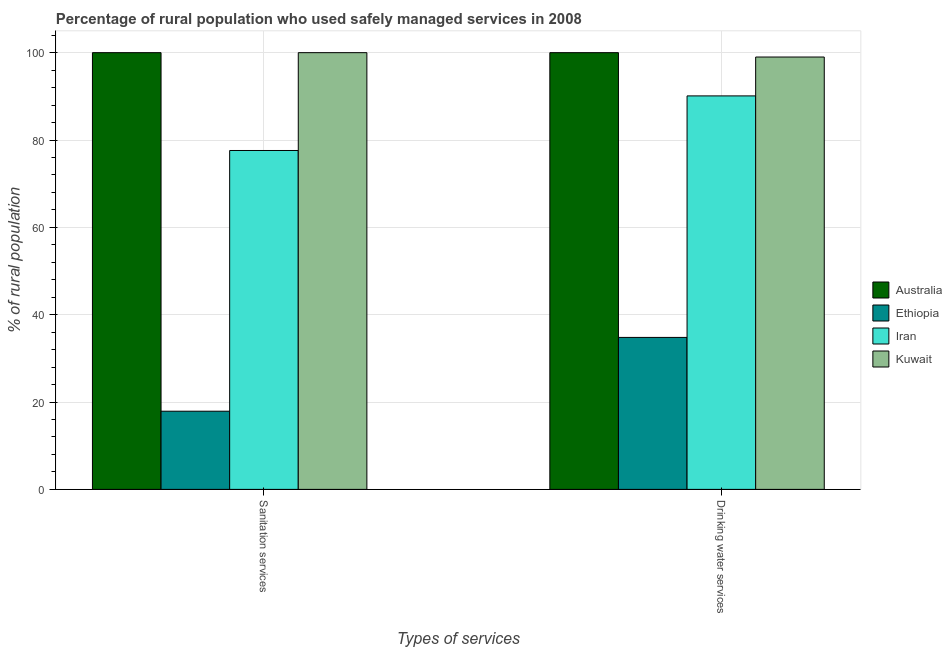How many groups of bars are there?
Your response must be concise. 2. Are the number of bars per tick equal to the number of legend labels?
Your response must be concise. Yes. Are the number of bars on each tick of the X-axis equal?
Provide a short and direct response. Yes. How many bars are there on the 1st tick from the left?
Your answer should be very brief. 4. How many bars are there on the 1st tick from the right?
Provide a short and direct response. 4. What is the label of the 1st group of bars from the left?
Your answer should be compact. Sanitation services. What is the percentage of rural population who used drinking water services in Ethiopia?
Keep it short and to the point. 34.8. Across all countries, what is the minimum percentage of rural population who used drinking water services?
Give a very brief answer. 34.8. In which country was the percentage of rural population who used sanitation services minimum?
Offer a very short reply. Ethiopia. What is the total percentage of rural population who used sanitation services in the graph?
Provide a succinct answer. 295.5. What is the difference between the percentage of rural population who used drinking water services in Ethiopia and that in Iran?
Give a very brief answer. -55.3. What is the difference between the percentage of rural population who used sanitation services in Kuwait and the percentage of rural population who used drinking water services in Iran?
Keep it short and to the point. 9.9. What is the average percentage of rural population who used drinking water services per country?
Offer a terse response. 80.97. What is the ratio of the percentage of rural population who used sanitation services in Iran to that in Australia?
Make the answer very short. 0.78. What does the 3rd bar from the left in Drinking water services represents?
Provide a short and direct response. Iran. What does the 1st bar from the right in Sanitation services represents?
Provide a short and direct response. Kuwait. How many bars are there?
Your answer should be compact. 8. How many countries are there in the graph?
Your answer should be very brief. 4. Where does the legend appear in the graph?
Provide a short and direct response. Center right. How are the legend labels stacked?
Ensure brevity in your answer.  Vertical. What is the title of the graph?
Your answer should be very brief. Percentage of rural population who used safely managed services in 2008. Does "Andorra" appear as one of the legend labels in the graph?
Your answer should be compact. No. What is the label or title of the X-axis?
Offer a very short reply. Types of services. What is the label or title of the Y-axis?
Your answer should be compact. % of rural population. What is the % of rural population in Australia in Sanitation services?
Give a very brief answer. 100. What is the % of rural population in Iran in Sanitation services?
Keep it short and to the point. 77.6. What is the % of rural population of Kuwait in Sanitation services?
Give a very brief answer. 100. What is the % of rural population of Ethiopia in Drinking water services?
Provide a succinct answer. 34.8. What is the % of rural population of Iran in Drinking water services?
Offer a very short reply. 90.1. Across all Types of services, what is the maximum % of rural population in Australia?
Offer a terse response. 100. Across all Types of services, what is the maximum % of rural population of Ethiopia?
Give a very brief answer. 34.8. Across all Types of services, what is the maximum % of rural population of Iran?
Your answer should be compact. 90.1. Across all Types of services, what is the minimum % of rural population in Australia?
Give a very brief answer. 100. Across all Types of services, what is the minimum % of rural population in Iran?
Provide a short and direct response. 77.6. What is the total % of rural population of Ethiopia in the graph?
Offer a terse response. 52.7. What is the total % of rural population of Iran in the graph?
Provide a short and direct response. 167.7. What is the total % of rural population in Kuwait in the graph?
Offer a terse response. 199. What is the difference between the % of rural population of Ethiopia in Sanitation services and that in Drinking water services?
Your response must be concise. -16.9. What is the difference between the % of rural population in Kuwait in Sanitation services and that in Drinking water services?
Make the answer very short. 1. What is the difference between the % of rural population in Australia in Sanitation services and the % of rural population in Ethiopia in Drinking water services?
Give a very brief answer. 65.2. What is the difference between the % of rural population in Ethiopia in Sanitation services and the % of rural population in Iran in Drinking water services?
Your answer should be very brief. -72.2. What is the difference between the % of rural population of Ethiopia in Sanitation services and the % of rural population of Kuwait in Drinking water services?
Give a very brief answer. -81.1. What is the difference between the % of rural population in Iran in Sanitation services and the % of rural population in Kuwait in Drinking water services?
Ensure brevity in your answer.  -21.4. What is the average % of rural population in Australia per Types of services?
Your response must be concise. 100. What is the average % of rural population of Ethiopia per Types of services?
Provide a short and direct response. 26.35. What is the average % of rural population in Iran per Types of services?
Your answer should be very brief. 83.85. What is the average % of rural population of Kuwait per Types of services?
Make the answer very short. 99.5. What is the difference between the % of rural population of Australia and % of rural population of Ethiopia in Sanitation services?
Make the answer very short. 82.1. What is the difference between the % of rural population of Australia and % of rural population of Iran in Sanitation services?
Your answer should be compact. 22.4. What is the difference between the % of rural population in Australia and % of rural population in Kuwait in Sanitation services?
Offer a terse response. 0. What is the difference between the % of rural population of Ethiopia and % of rural population of Iran in Sanitation services?
Your answer should be very brief. -59.7. What is the difference between the % of rural population of Ethiopia and % of rural population of Kuwait in Sanitation services?
Provide a succinct answer. -82.1. What is the difference between the % of rural population of Iran and % of rural population of Kuwait in Sanitation services?
Make the answer very short. -22.4. What is the difference between the % of rural population in Australia and % of rural population in Ethiopia in Drinking water services?
Your answer should be very brief. 65.2. What is the difference between the % of rural population of Australia and % of rural population of Iran in Drinking water services?
Your response must be concise. 9.9. What is the difference between the % of rural population in Ethiopia and % of rural population in Iran in Drinking water services?
Provide a succinct answer. -55.3. What is the difference between the % of rural population of Ethiopia and % of rural population of Kuwait in Drinking water services?
Ensure brevity in your answer.  -64.2. What is the difference between the % of rural population of Iran and % of rural population of Kuwait in Drinking water services?
Your response must be concise. -8.9. What is the ratio of the % of rural population in Ethiopia in Sanitation services to that in Drinking water services?
Your response must be concise. 0.51. What is the ratio of the % of rural population in Iran in Sanitation services to that in Drinking water services?
Your answer should be compact. 0.86. What is the ratio of the % of rural population of Kuwait in Sanitation services to that in Drinking water services?
Offer a very short reply. 1.01. What is the difference between the highest and the second highest % of rural population in Ethiopia?
Your response must be concise. 16.9. What is the difference between the highest and the second highest % of rural population of Iran?
Make the answer very short. 12.5. What is the difference between the highest and the second highest % of rural population of Kuwait?
Your answer should be compact. 1. What is the difference between the highest and the lowest % of rural population in Ethiopia?
Make the answer very short. 16.9. 